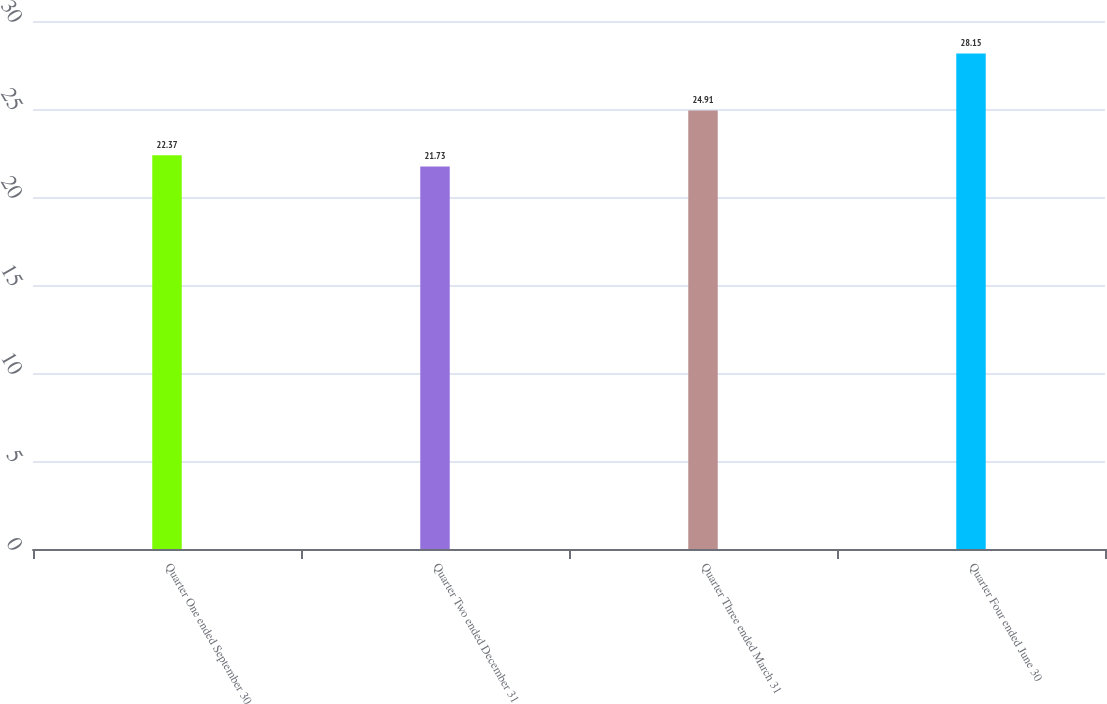Convert chart. <chart><loc_0><loc_0><loc_500><loc_500><bar_chart><fcel>Quarter One ended September 30<fcel>Quarter Two ended December 31<fcel>Quarter Three ended March 31<fcel>Quarter Four ended June 30<nl><fcel>22.37<fcel>21.73<fcel>24.91<fcel>28.15<nl></chart> 